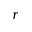Convert formula to latex. <formula><loc_0><loc_0><loc_500><loc_500>{ r }</formula> 